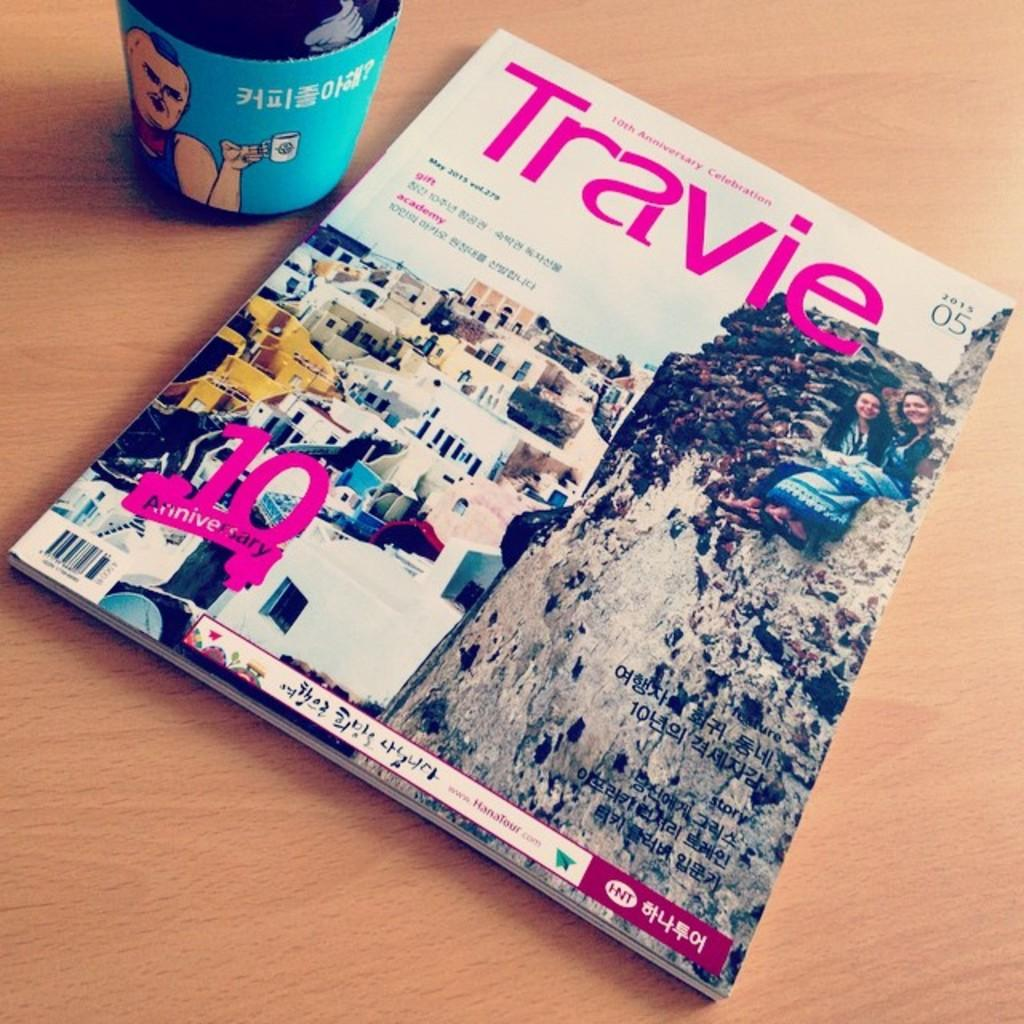<image>
Give a short and clear explanation of the subsequent image. A travel magazine titled Travie lying on a table next to a cup. 